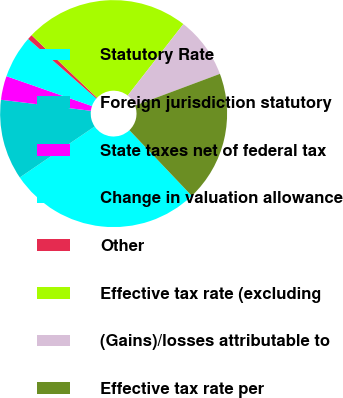<chart> <loc_0><loc_0><loc_500><loc_500><pie_chart><fcel>Statutory Rate<fcel>Foreign jurisdiction statutory<fcel>State taxes net of federal tax<fcel>Change in valuation allowance<fcel>Other<fcel>Effective tax rate (excluding<fcel>(Gains)/losses attributable to<fcel>Effective tax rate per<nl><fcel>27.58%<fcel>11.46%<fcel>3.4%<fcel>6.08%<fcel>0.71%<fcel>23.4%<fcel>8.77%<fcel>18.6%<nl></chart> 